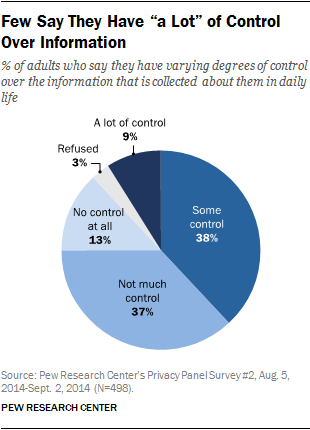Specify some key components in this picture. The ratio between "Refused" and "A lot of control" is 0.33. The study found that Not much control accounted for 0.37% of the variance in outcome 1. 